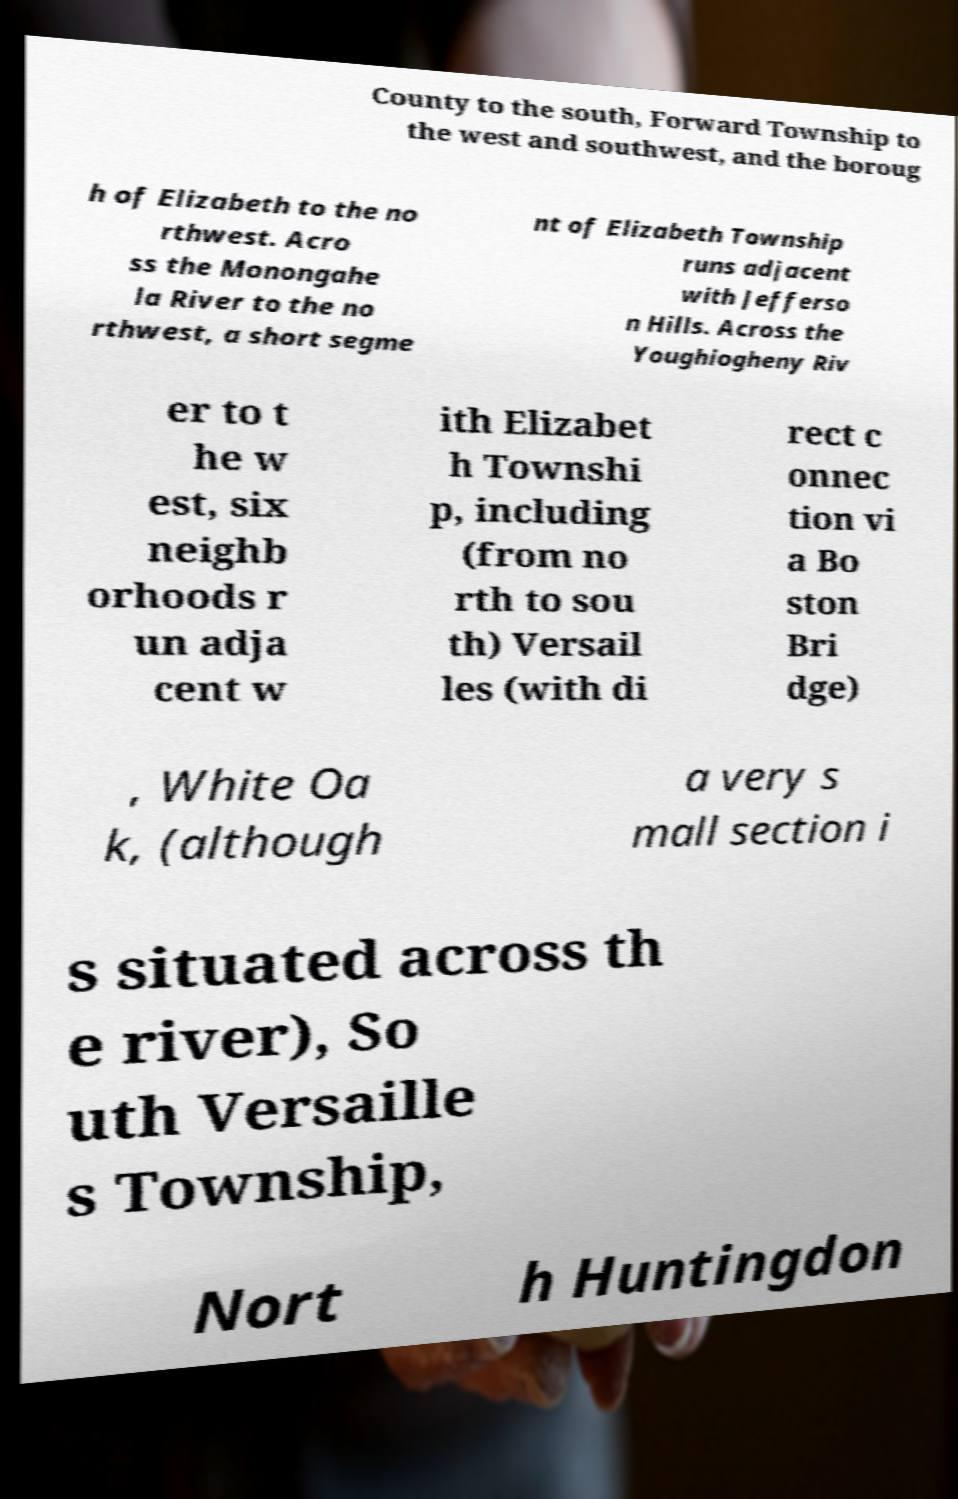Please read and relay the text visible in this image. What does it say? County to the south, Forward Township to the west and southwest, and the boroug h of Elizabeth to the no rthwest. Acro ss the Monongahe la River to the no rthwest, a short segme nt of Elizabeth Township runs adjacent with Jefferso n Hills. Across the Youghiogheny Riv er to t he w est, six neighb orhoods r un adja cent w ith Elizabet h Townshi p, including (from no rth to sou th) Versail les (with di rect c onnec tion vi a Bo ston Bri dge) , White Oa k, (although a very s mall section i s situated across th e river), So uth Versaille s Township, Nort h Huntingdon 